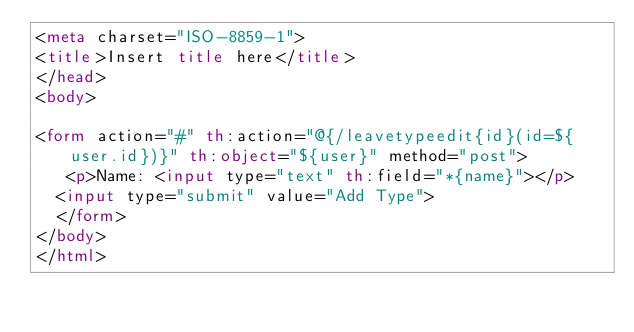<code> <loc_0><loc_0><loc_500><loc_500><_HTML_><meta charset="ISO-8859-1">
<title>Insert title here</title>
</head>
<body>

<form action="#" th:action="@{/leavetypeedit{id}(id=${user.id})}" th:object="${user}" method="post">
   <p>Name: <input type="text" th:field="*{name}"></p>   
	<input type="submit" value="Add Type"> 
	</form>
</body>
</html></code> 